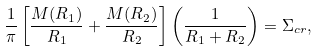<formula> <loc_0><loc_0><loc_500><loc_500>\frac { 1 } { \pi } \left [ \frac { M ( R _ { 1 } ) } { R _ { 1 } } + \frac { M ( R _ { 2 } ) } { R _ { 2 } } \right ] \left ( \frac { 1 } { R _ { 1 } + R _ { 2 } } \right ) = \Sigma _ { c r } ,</formula> 